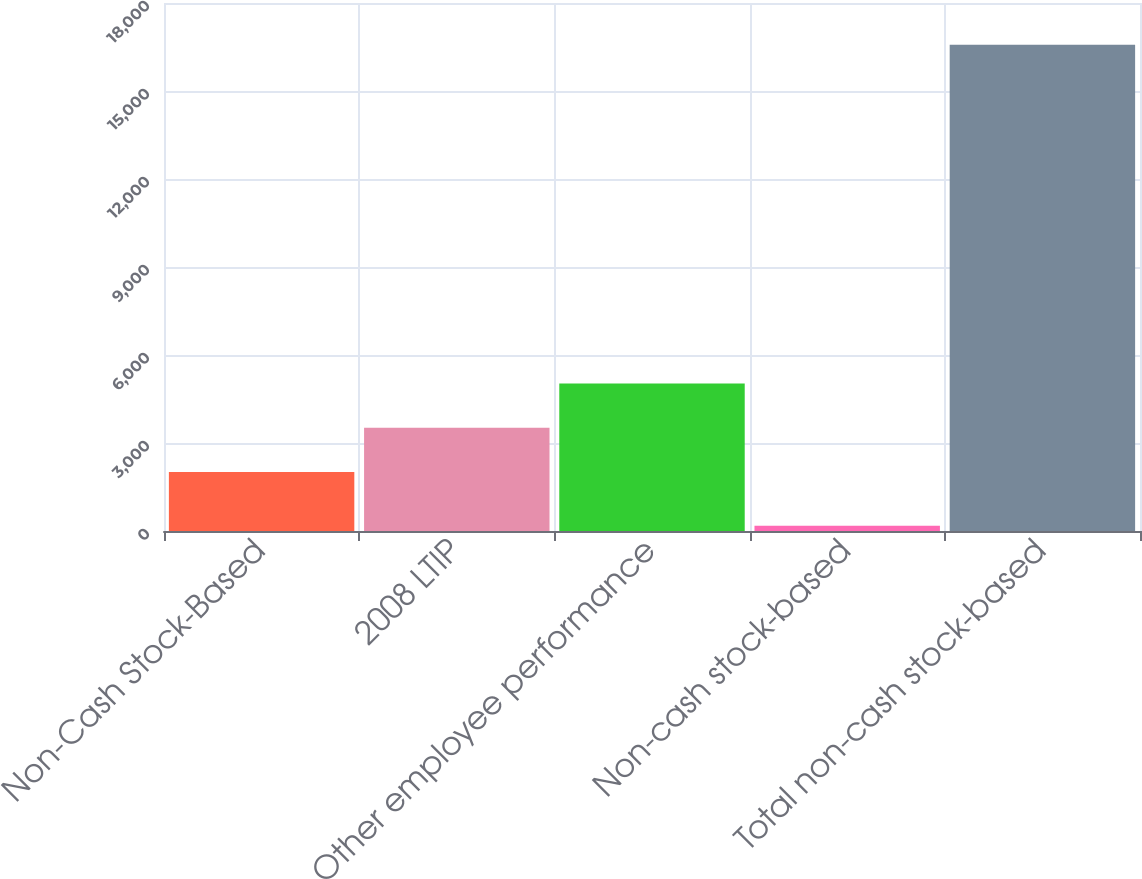<chart> <loc_0><loc_0><loc_500><loc_500><bar_chart><fcel>Non-Cash Stock-Based<fcel>2008 LTIP<fcel>Other employee performance<fcel>Non-cash stock-based<fcel>Total non-cash stock-based<nl><fcel>2013<fcel>3520.1<fcel>5027.2<fcel>182<fcel>16578.1<nl></chart> 